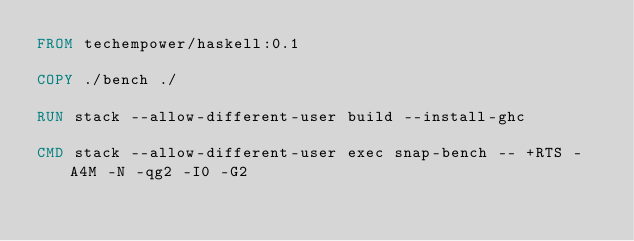Convert code to text. <code><loc_0><loc_0><loc_500><loc_500><_Dockerfile_>FROM techempower/haskell:0.1

COPY ./bench ./

RUN stack --allow-different-user build --install-ghc

CMD stack --allow-different-user exec snap-bench -- +RTS -A4M -N -qg2 -I0 -G2
</code> 